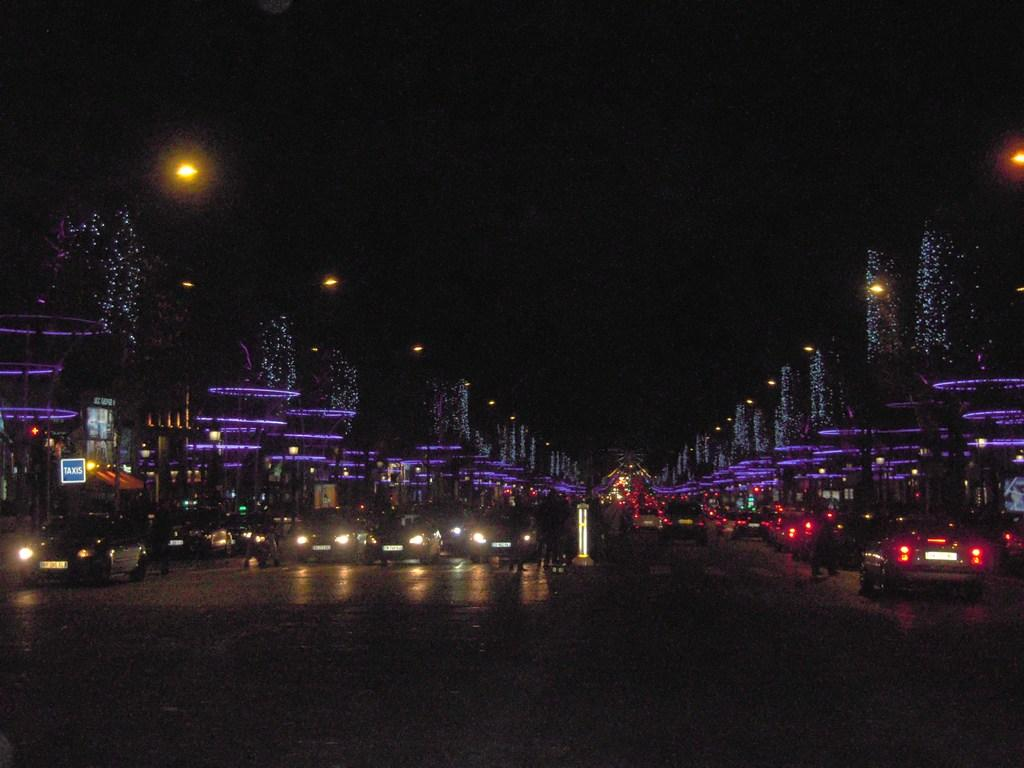Where was the image taken? The image was clicked outside. What is the main subject of the image? There is a group of vehicles in the center of the image. What can be seen in addition to the vehicles? There are lights visible in the image, as well as other objects. How would you describe the lighting conditions in the image? The background of the image is very dark. What type of button is being used by the guide to give a haircut in the image? There is no guide, button, or haircut present in the image. 